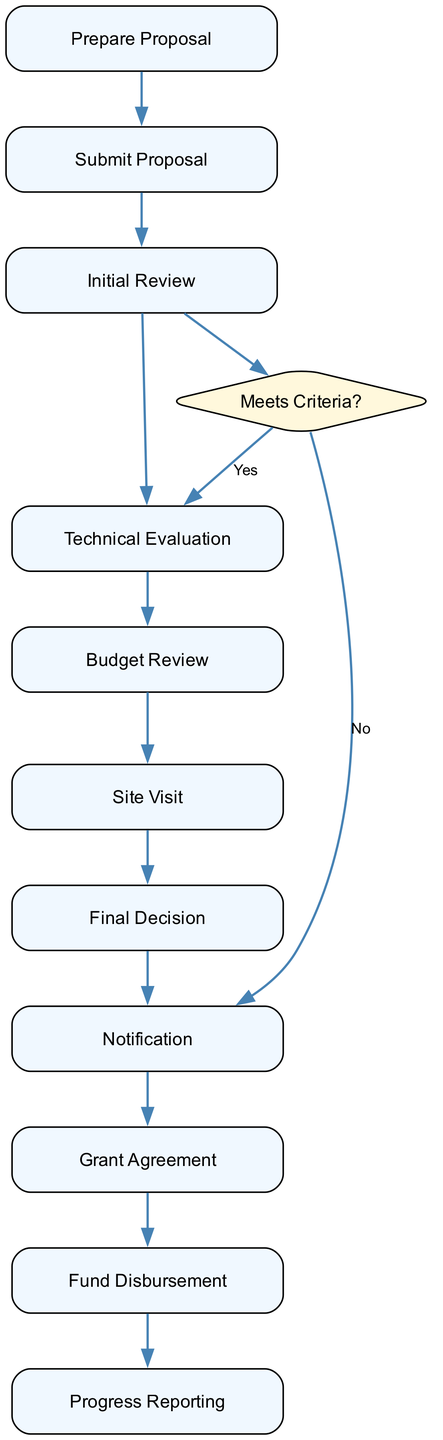What is the first activity in the grant application process? The first activity listed in the diagram is "Prepare Proposal". This is the first node in the sequence of activities that the researchers undertake when applying for the grant.
Answer: Prepare Proposal How many activities are there in the process? To answer this, we count the number of nodes representing activities in the diagram. There are 11 nodes listed in the provided data, signifying 11 activities in total.
Answer: 11 What happens after the "Initial Review"? After the "Initial Review", there is a decision node labeled "Meets Criteria?" which branches to either "Technical Evaluation" or "Notification" based on the criteria met. This shows that the next steps depend on whether the proposal meets the eligibility criteria.
Answer: Technical Evaluation Is a site visit always required? No, a site visit is only conducted if needed, as indicated in the description for the "Site Visit" activity. This is contingent upon the results of previous evaluations.
Answer: No What is the decision node in the diagram labeled? The decision node in the diagram is labeled "Meets Criteria?". This node indicates a critical point in the process where a determination is made regarding the progress of the application based on initial reviews.
Answer: Meets Criteria? Which activity follows "Budget Review"? The activity that follows "Budget Review" is dependent on the outcome from the decision node "Meets Criteria?". If the criteria are met, it goes to "Technical Evaluation"; otherwise, it moves to "Notification". This illustrates that Budget Review leads to an important decision point.
Answer: Decision Node How does the process conclude for successful applicants? The process concludes for successful applicants with the "Fund Disbursement" activity, which signifies that funds are allocated to approved projects based on the previously signed grant agreement. This is the final step in the flow for granted applications.
Answer: Fund Disbursement What type of experts conduct the technical evaluation? The technical evaluation is conducted by a "panel of experts", focusing on assessing the technical merits of the proposal, which relates to its innovation and feasibility as a solar technology research project.
Answer: Panel of experts What is the purpose of the "Progress Reporting" activity? The "Progress Reporting" activity serves the purpose of ensuring that researchers regularly inform the grant program about the status of their project, including advancements and challenges. This is crucial for monitoring and accountability throughout the grant period.
Answer: Monitoring progress 